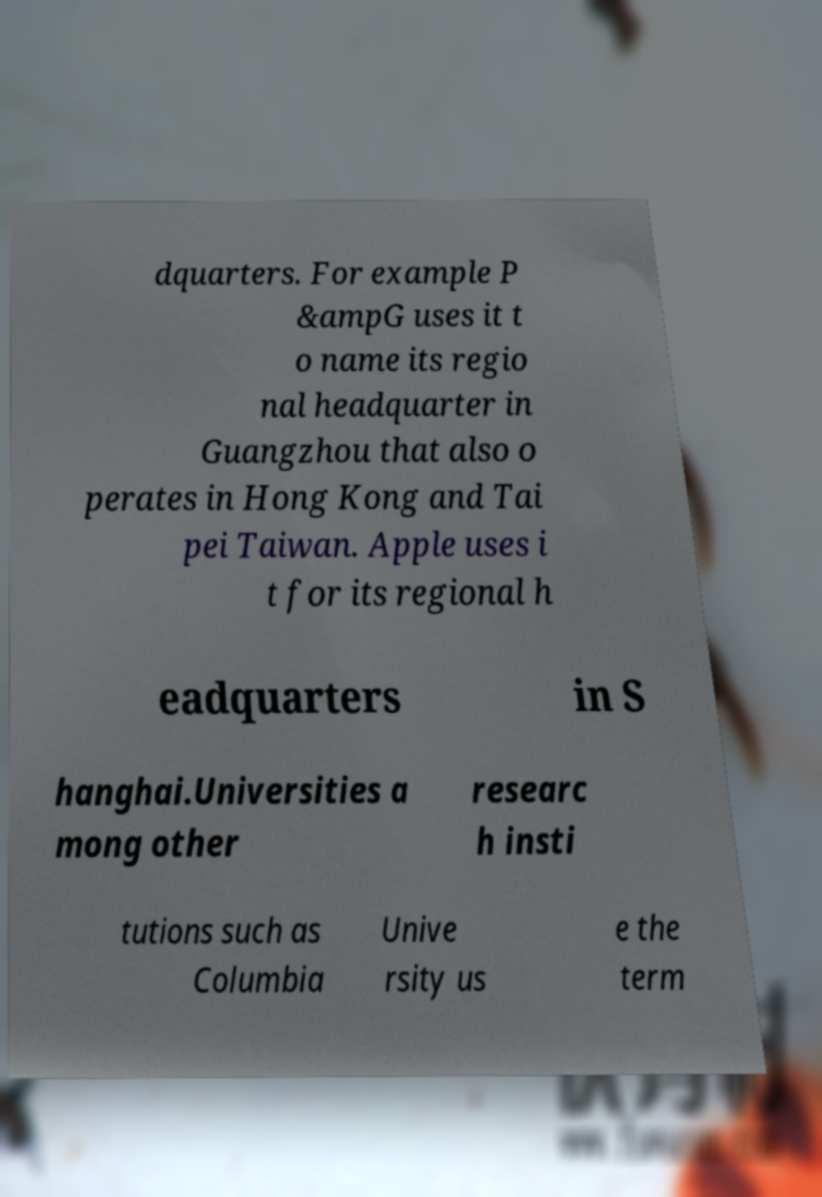Could you extract and type out the text from this image? dquarters. For example P &ampG uses it t o name its regio nal headquarter in Guangzhou that also o perates in Hong Kong and Tai pei Taiwan. Apple uses i t for its regional h eadquarters in S hanghai.Universities a mong other researc h insti tutions such as Columbia Unive rsity us e the term 